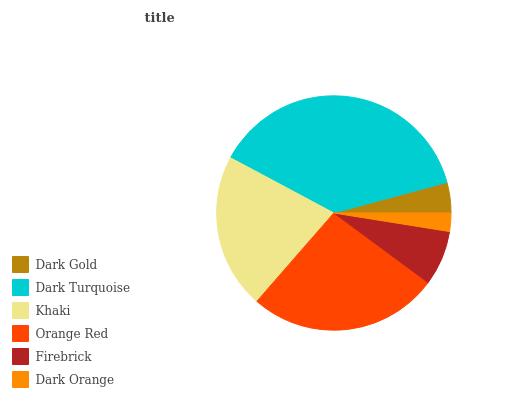Is Dark Orange the minimum?
Answer yes or no. Yes. Is Dark Turquoise the maximum?
Answer yes or no. Yes. Is Khaki the minimum?
Answer yes or no. No. Is Khaki the maximum?
Answer yes or no. No. Is Dark Turquoise greater than Khaki?
Answer yes or no. Yes. Is Khaki less than Dark Turquoise?
Answer yes or no. Yes. Is Khaki greater than Dark Turquoise?
Answer yes or no. No. Is Dark Turquoise less than Khaki?
Answer yes or no. No. Is Khaki the high median?
Answer yes or no. Yes. Is Firebrick the low median?
Answer yes or no. Yes. Is Dark Orange the high median?
Answer yes or no. No. Is Dark Turquoise the low median?
Answer yes or no. No. 